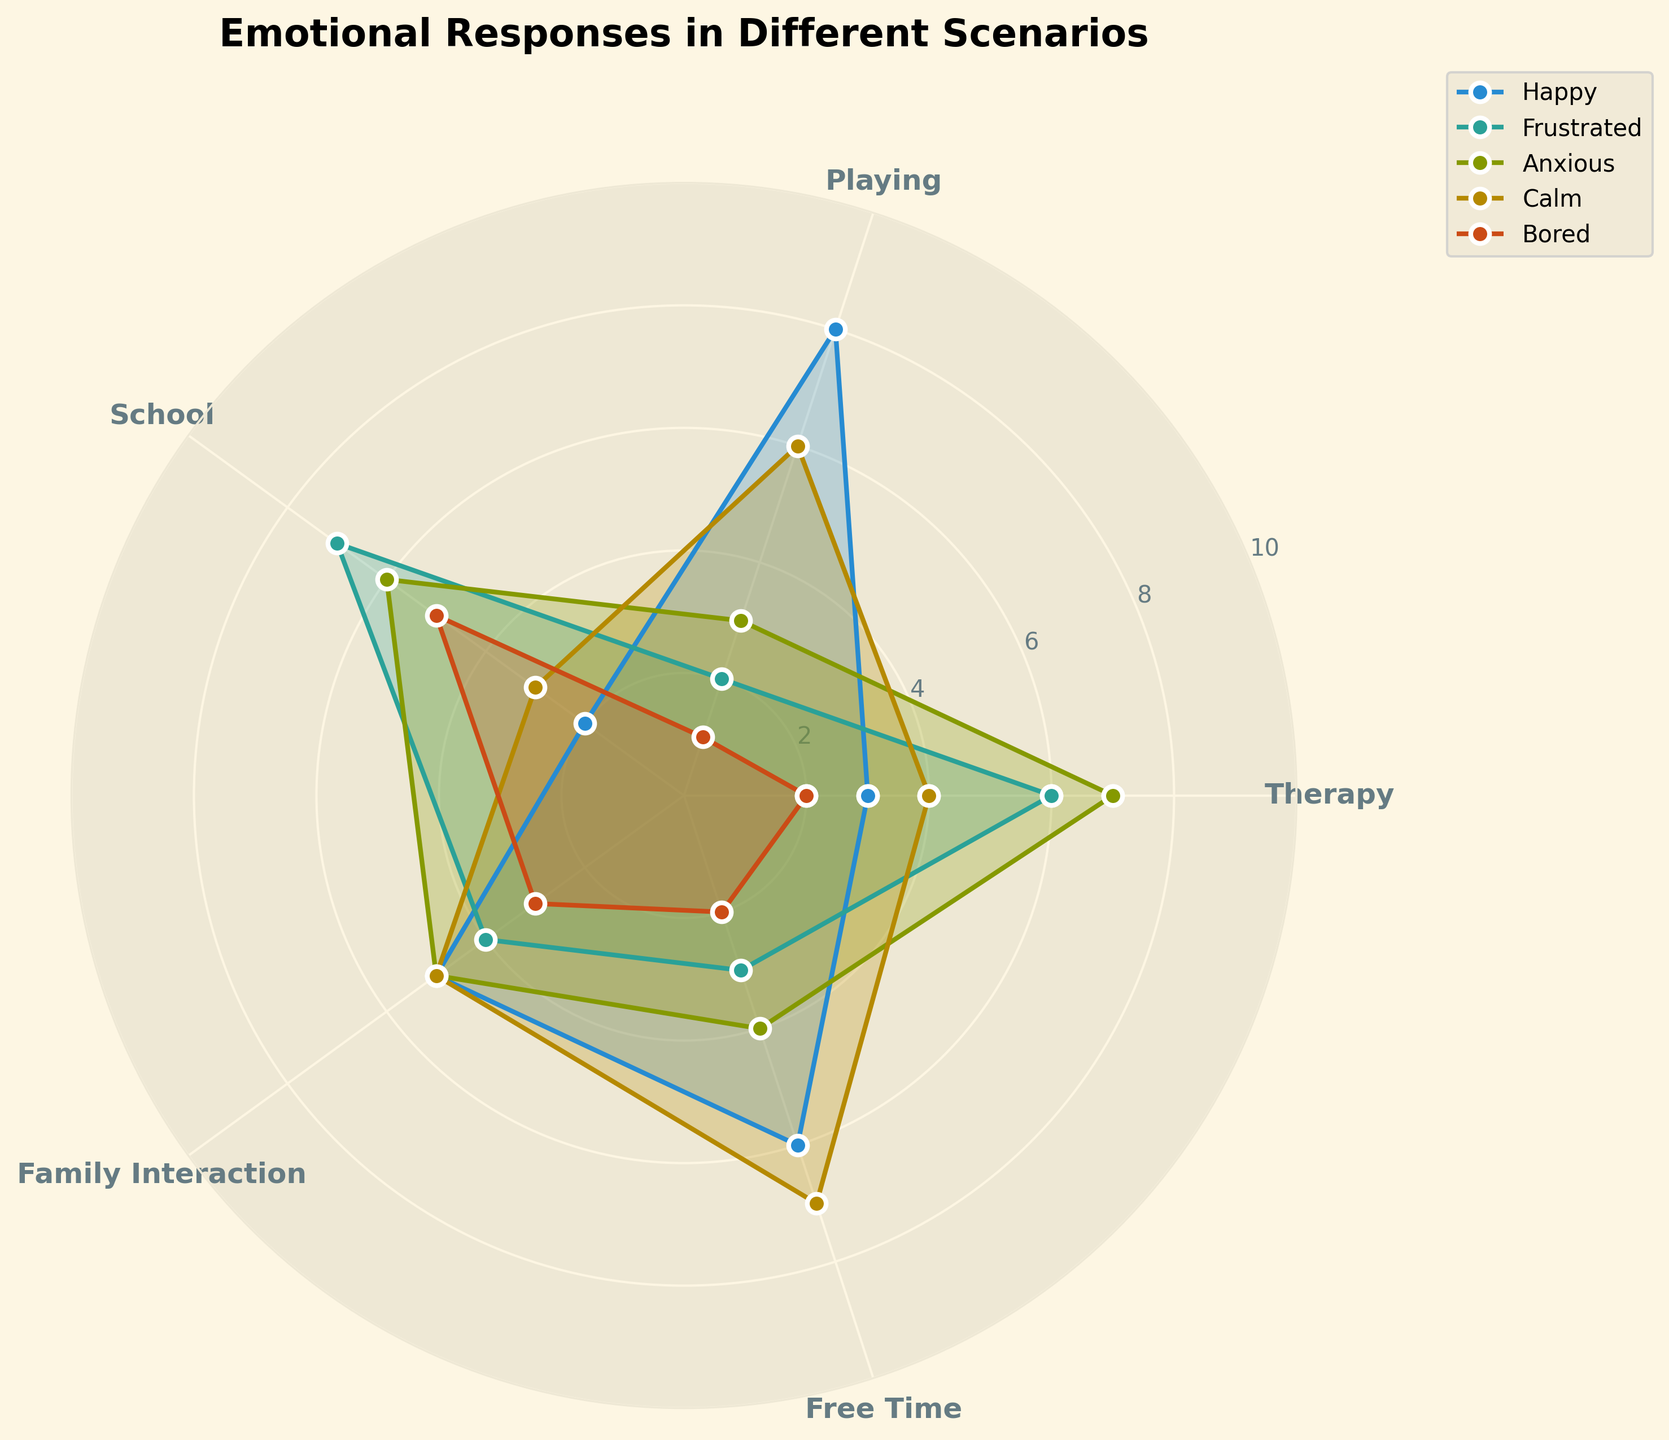What's the title of the figure? The title is typically located at the top of the chart and is usually the largest text that summarizes the plot. The title of the figure is "Emotional Responses in Different Scenarios".
Answer: Emotional Responses in Different Scenarios Which emotion has the highest value during therapy? To find this, we look at the values for each emotion in the therapy scenario. The values are Happy (3), Frustrated (6), Anxious (7), Calm (4), Bored (2). The highest value is for Anxious (7).
Answer: Anxious Compare the level of happiness during playing and during school. Which is higher? Check the happiness values for both scenarios: during playing (8) and during school (2). Since 8 is greater than 2, happiness is higher during playing.
Answer: Playing What's the total sum of frustration levels across all scenarios? Add the frustration values for each scenario: Therapy (6), Playing (2), School (7), Family Interaction (4), Free Time (3). Sum = 6 + 2 + 7 + 4 + 3 = 22.
Answer: 22 Is the participant calmer during free time or during family interactions? Compare the calmness values: Free Time (7) and Family Interaction (5). Since 7 is greater than 5, the participant is calmer during free time.
Answer: Free time Which scenario shows the lowest level of boredom? Look at the boredom values for each scenario: Therapy (2), Playing (1), School (5), Family Interaction (3), Free Time (2). The lowest value is for Playing (1).
Answer: Playing What is the median value of anxiety levels across all scenarios? List the anxiety values in ascending order: 3 (Playing), 4 (Free Time), 5 (Family Interaction), 6 (School), 7 (Therapy). The median (middle) value here is the third one, which is 5.
Answer: 5 What are the maximum and minimum levels of calmness in any scenario? Look at the calmness values: Therapy (4), Playing (6), School (3), Family Interaction (5), Free Time (7). The maximum is 7 and the minimum is 3.
Answer: Maximum: 7, Minimum: 3 In which scenario is boredom second highest? Arrange the boredom values in descending order: 5 (School), 3 (Family Interaction), 2 (Therapy), 2 (Free Time), 1 (Playing). The second highest is for Family Interaction (3).
Answer: Family interaction 